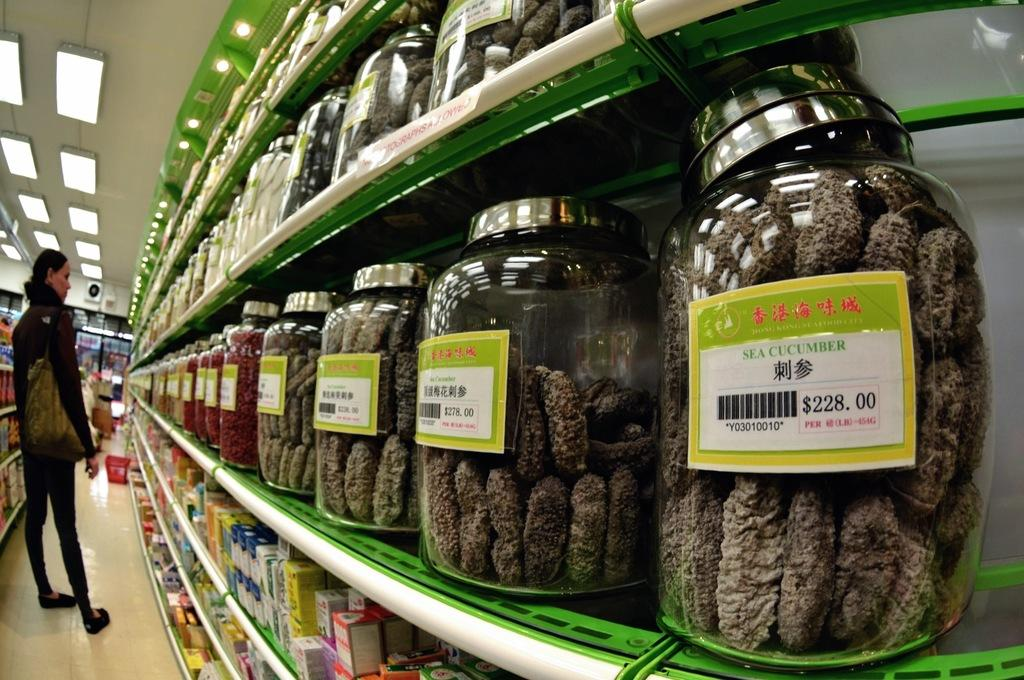<image>
Summarize the visual content of the image. A jar of sea cucumber that is being sold for 228 dollars. 